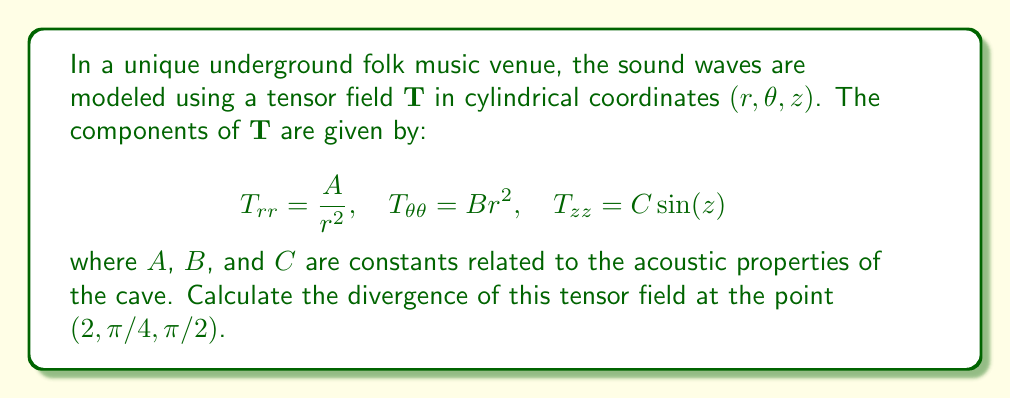Provide a solution to this math problem. To solve this problem, we need to follow these steps:

1) The divergence of a tensor field in cylindrical coordinates is given by:

   $$\nabla \cdot \mathbf{T} = \frac{1}{r}\frac{\partial(rT_{rr})}{\partial r} + \frac{1}{r}\frac{\partial T_{\theta\theta}}{\partial \theta} + \frac{\partial T_{zz}}{\partial z}$$

2) Let's calculate each term separately:

   a) $\frac{1}{r}\frac{\partial(rT_{rr})}{\partial r}$:
      $rT_{rr} = r \cdot \frac{A}{r^2} = \frac{A}{r}$
      $\frac{\partial(rT_{rr})}{\partial r} = -\frac{A}{r^2}$
      $\frac{1}{r}\frac{\partial(rT_{rr})}{\partial r} = -\frac{A}{r^3}$

   b) $\frac{1}{r}\frac{\partial T_{\theta\theta}}{\partial \theta}$:
      $T_{\theta\theta} = Br^2$, which is not a function of $\theta$
      So, $\frac{1}{r}\frac{\partial T_{\theta\theta}}{\partial \theta} = 0$

   c) $\frac{\partial T_{zz}}{\partial z}$:
      $T_{zz} = C\sin(z)$
      $\frac{\partial T_{zz}}{\partial z} = C\cos(z)$

3) Combining these terms:

   $$\nabla \cdot \mathbf{T} = -\frac{A}{r^3} + 0 + C\cos(z)$$

4) Now, we evaluate this at the point $(2, \pi/4, \pi/2)$:

   $$\nabla \cdot \mathbf{T} |_{(2, \pi/4, \pi/2)} = -\frac{A}{2^3} + C\cos(\pi/2) = -\frac{A}{8} + 0 = -\frac{A}{8}$$

Therefore, the divergence of the tensor field at the given point is $-A/8$.
Answer: $-A/8$ 